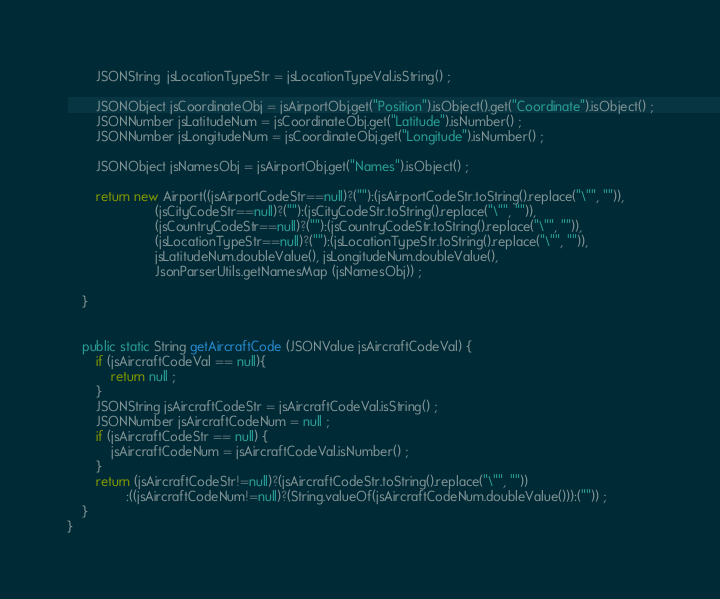<code> <loc_0><loc_0><loc_500><loc_500><_Java_>		JSONString  jsLocationTypeStr = jsLocationTypeVal.isString() ;
			
		JSONObject jsCoordinateObj = jsAirportObj.get("Position").isObject().get("Coordinate").isObject() ;
		JSONNumber jsLatitudeNum = jsCoordinateObj.get("Latitude").isNumber() ;
		JSONNumber jsLongitudeNum = jsCoordinateObj.get("Longitude").isNumber() ;
		
		JSONObject jsNamesObj = jsAirportObj.get("Names").isObject() ; 
				
		return new Airport((jsAirportCodeStr==null)?(""):(jsAirportCodeStr.toString().replace("\"", "")), 
						(jsCityCodeStr==null)?(""):(jsCityCodeStr.toString().replace("\"", "")), 
						(jsCountryCodeStr==null)?(""):(jsCountryCodeStr.toString().replace("\"", "")), 
						(jsLocationTypeStr==null)?(""):(jsLocationTypeStr.toString().replace("\"", "")),
						jsLatitudeNum.doubleValue(), jsLongitudeNum.doubleValue(), 
						JsonParserUtils.getNamesMap (jsNamesObj)) ;
		
	}
	
	
	public static String getAircraftCode (JSONValue jsAircraftCodeVal) {
		if (jsAircraftCodeVal == null){
			return null ;
		}
		JSONString jsAircraftCodeStr = jsAircraftCodeVal.isString() ;
		JSONNumber jsAircraftCodeNum = null ;
		if (jsAircraftCodeStr == null) {
			jsAircraftCodeNum = jsAircraftCodeVal.isNumber() ;
		}
		return (jsAircraftCodeStr!=null)?(jsAircraftCodeStr.toString().replace("\"", ""))
				:((jsAircraftCodeNum!=null)?(String.valueOf(jsAircraftCodeNum.doubleValue())):("")) ;
	}
}
</code> 